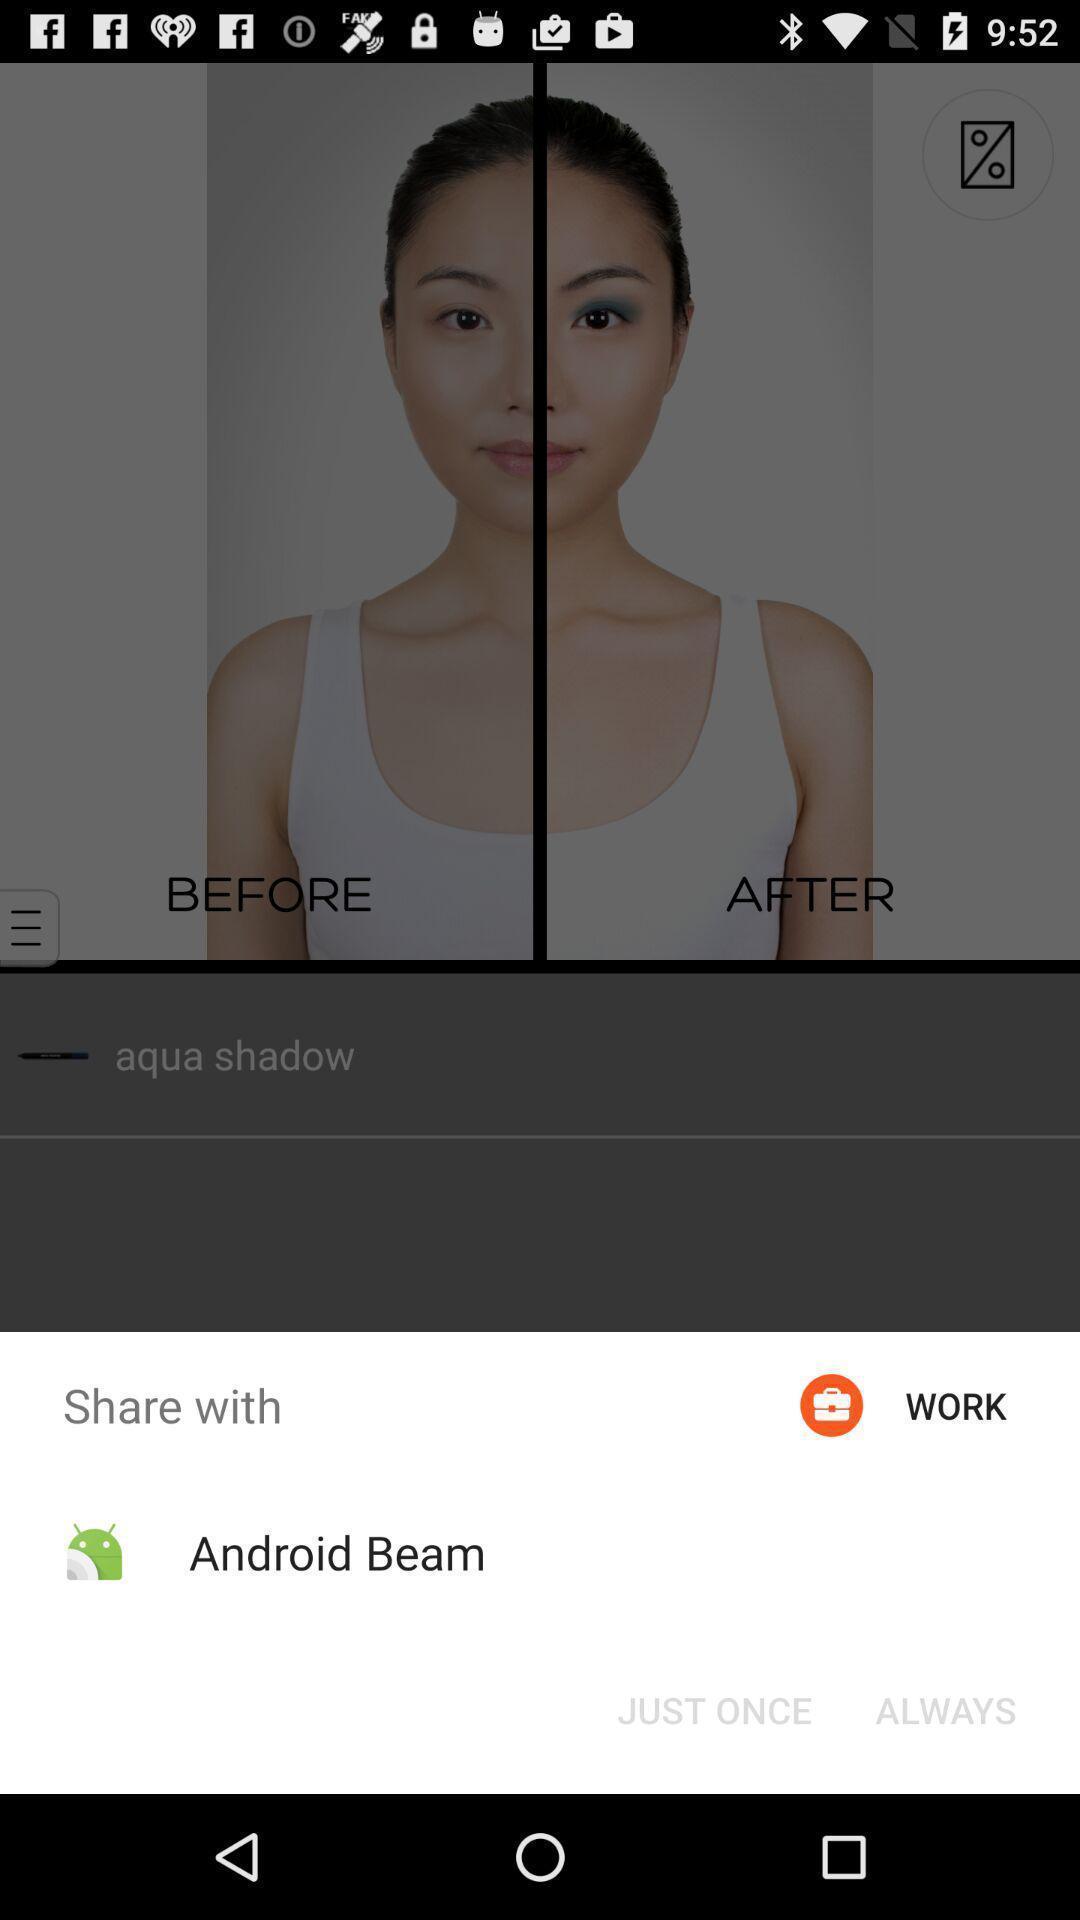Explain the elements present in this screenshot. Pop up of sharing image with social media. 